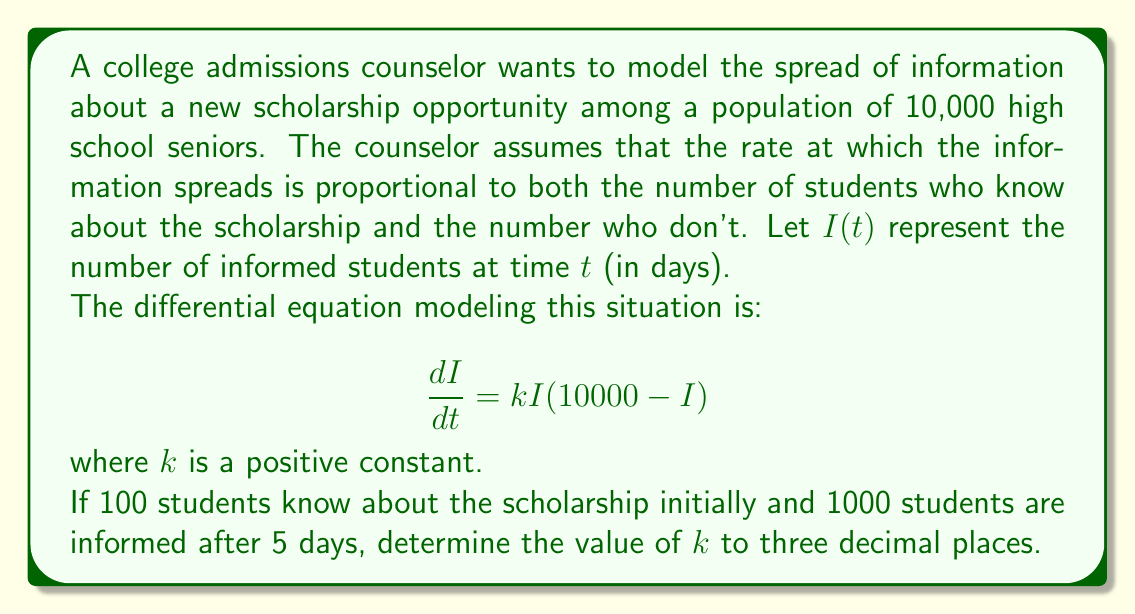Help me with this question. To solve this problem, we'll use the logistic growth model, which is a common epidemic model for information spread. Let's approach this step-by-step:

1) The general solution to the logistic equation is:

   $$I(t) = \frac{N}{1 + Ce^{-kNt}}$$

   where $N$ is the total population (10,000 in this case) and $C$ is a constant we need to determine.

2) We know that initially, $I(0) = 100$. Let's use this to find $C$:

   $$100 = \frac{10000}{1 + C}$$
   $$C = 99$$

3) Now our equation is:

   $$I(t) = \frac{10000}{1 + 99e^{-10000kt}}$$

4) We're told that after 5 days, 1000 students are informed. Let's use this information:

   $$1000 = \frac{10000}{1 + 99e^{-50000k}}$$

5) Solving for $k$:

   $$1 + 99e^{-50000k} = 10$$
   $$99e^{-50000k} = 9$$
   $$e^{-50000k} = \frac{9}{99} = \frac{1}{11}$$
   $$-50000k = \ln(\frac{1}{11})$$
   $$k = -\frac{\ln(\frac{1}{11})}{50000} = \frac{\ln(11)}{50000}$$

6) Calculating this value:

   $$k \approx 0.000048216$$

7) Rounding to three decimal places:

   $$k \approx 0.000$$
Answer: $k \approx 0.000$ 